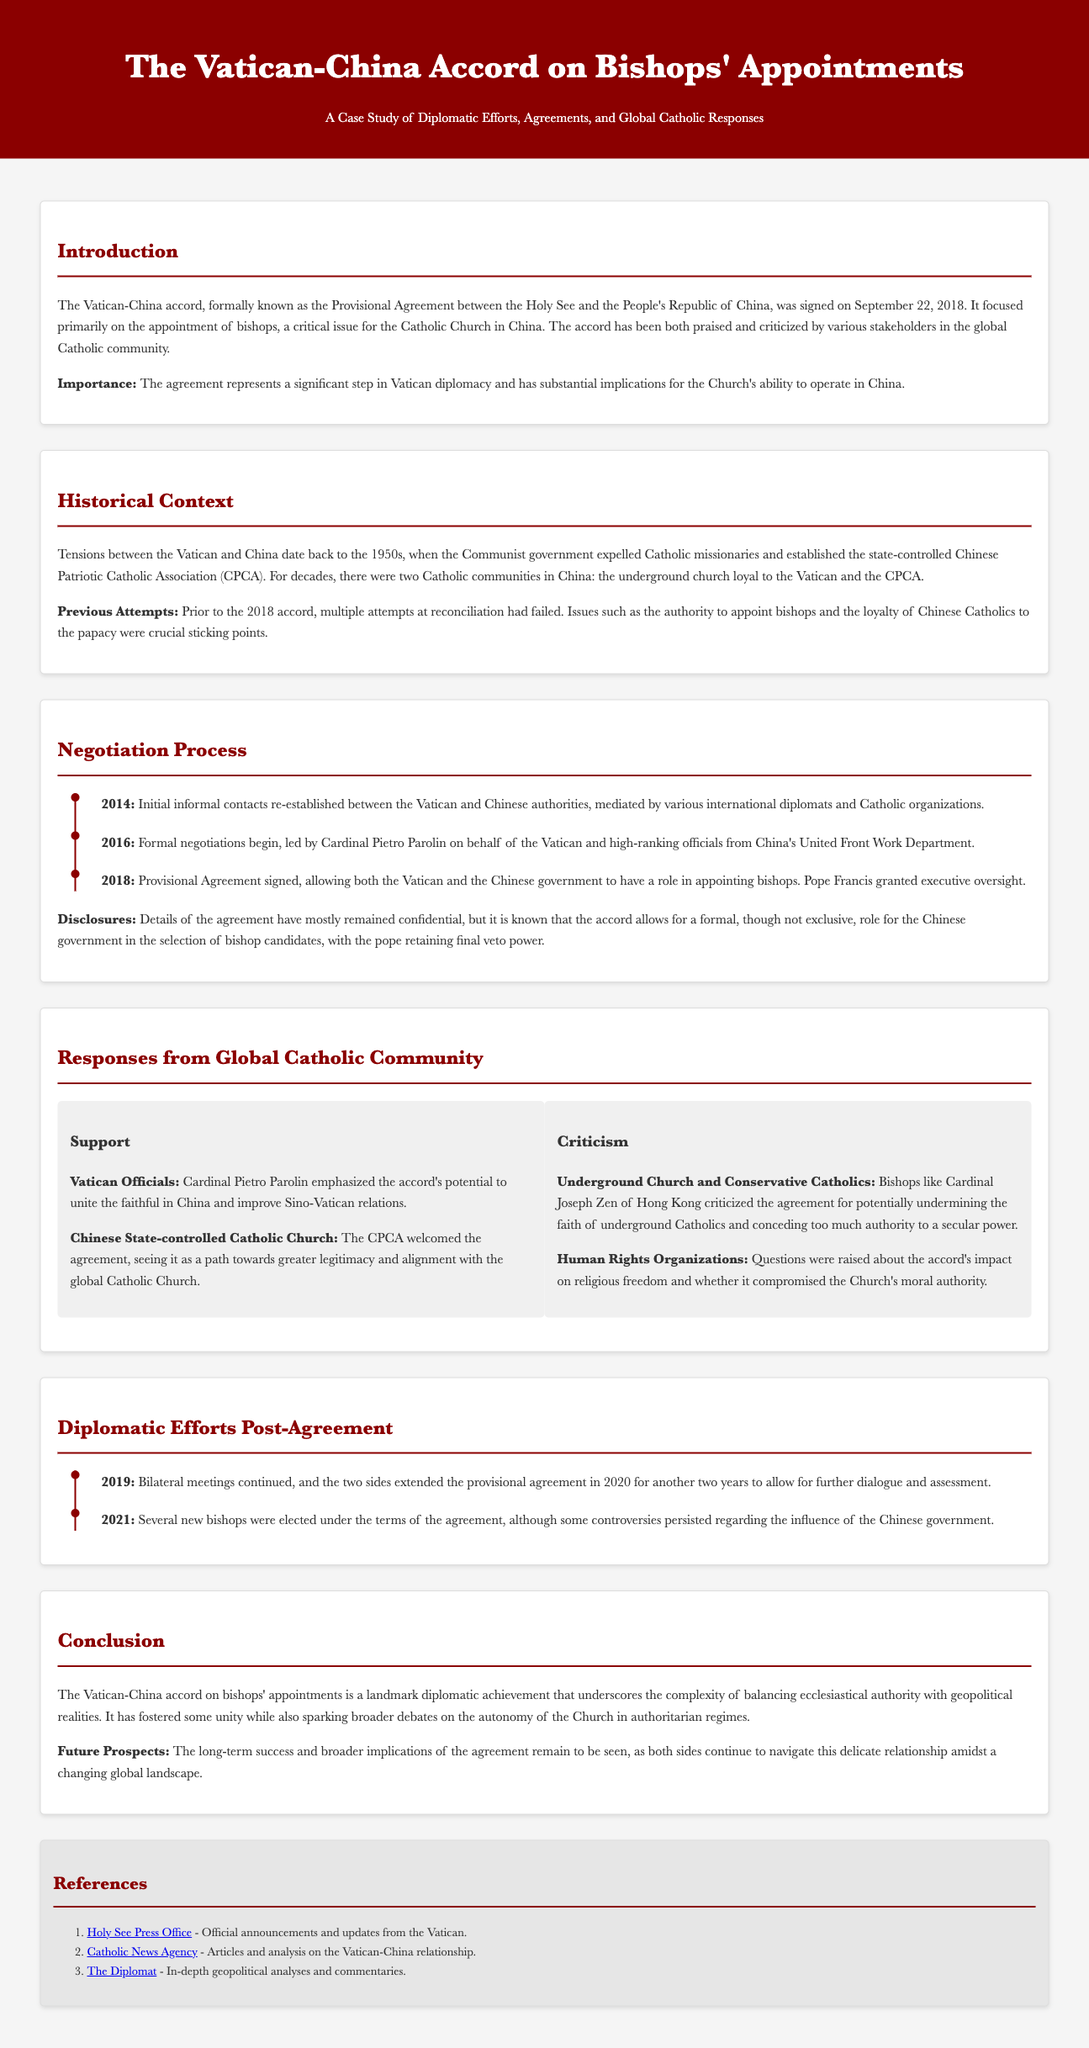What is the date the Vatican-China accord was signed? The date is noted in the introduction of the document as the agreement was signed on September 22, 2018.
Answer: September 22, 2018 Who emphasized the accord's potential to unite the faithful in China? This information is found in the "Support" section of the global Catholic community responses, where Cardinal Pietro Parolin's comments are mentioned.
Answer: Cardinal Pietro Parolin What is the primary focus of the Vatican-China accord? The introduction of the document indicates that the primary focus is on the appointment of bishops.
Answer: Appointment of bishops In what year did formal negotiations begin? The timeline in the negotiation process section states that formal negotiations began in 2016.
Answer: 2016 Which organization sees the agreement as a path towards greater legitimacy? The response from the Chinese state-controlled Catholic Church indicates that the CPCA welcomes the agreement for that reason.
Answer: CPCA Who criticized the agreement for potentially undermining the faith of underground Catholics? This criticism is made by Cardinal Joseph Zen of Hong Kong according to the "Criticism" section.
Answer: Cardinal Joseph Zen What significant event occurred in 2021 under the terms of the agreement? The timeline states that several new bishops were elected in that year under the accord.
Answer: New bishops elected What are two key stakeholders in the criticism of the accord? The "Criticism" section refers to the underground church and human rights organizations as key critics.
Answer: Underground church and human rights organizations What does the accord allow regarding the role of the Chinese government? The details mentioned in the negotiation process indicate that the accord allows for a formal, though not exclusive, role for the Chinese government in bishop selection.
Answer: Formal role for the Chinese government 